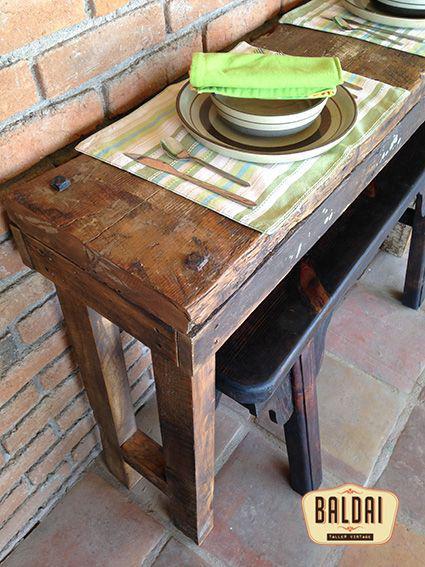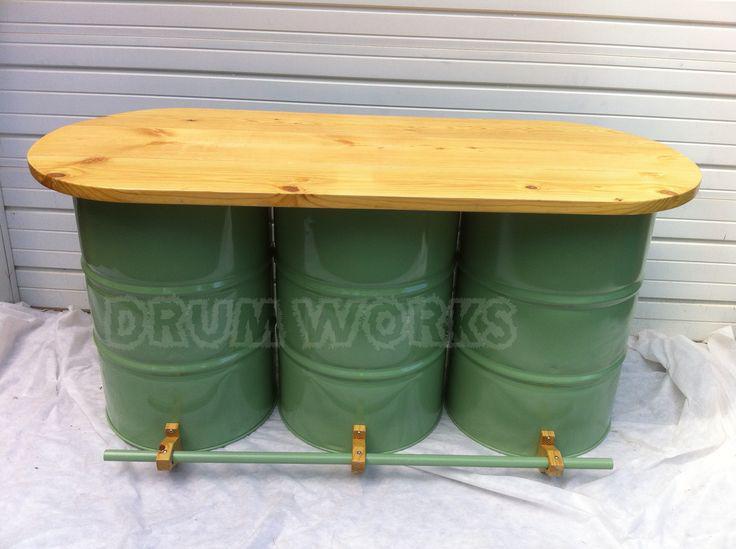The first image is the image on the left, the second image is the image on the right. Examine the images to the left and right. Is the description "There is a total of three green barrell with a wooden table top." accurate? Answer yes or no. Yes. The first image is the image on the left, the second image is the image on the right. For the images displayed, is the sentence "There are three green drums, with a wooden table running across the top of the drums." factually correct? Answer yes or no. Yes. 